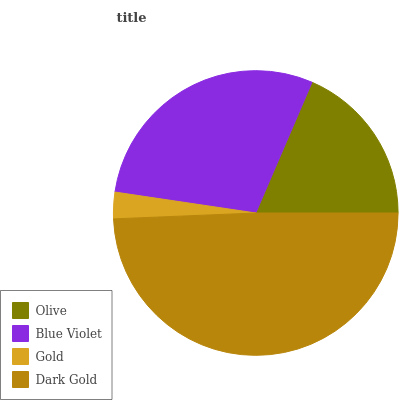Is Gold the minimum?
Answer yes or no. Yes. Is Dark Gold the maximum?
Answer yes or no. Yes. Is Blue Violet the minimum?
Answer yes or no. No. Is Blue Violet the maximum?
Answer yes or no. No. Is Blue Violet greater than Olive?
Answer yes or no. Yes. Is Olive less than Blue Violet?
Answer yes or no. Yes. Is Olive greater than Blue Violet?
Answer yes or no. No. Is Blue Violet less than Olive?
Answer yes or no. No. Is Blue Violet the high median?
Answer yes or no. Yes. Is Olive the low median?
Answer yes or no. Yes. Is Gold the high median?
Answer yes or no. No. Is Blue Violet the low median?
Answer yes or no. No. 